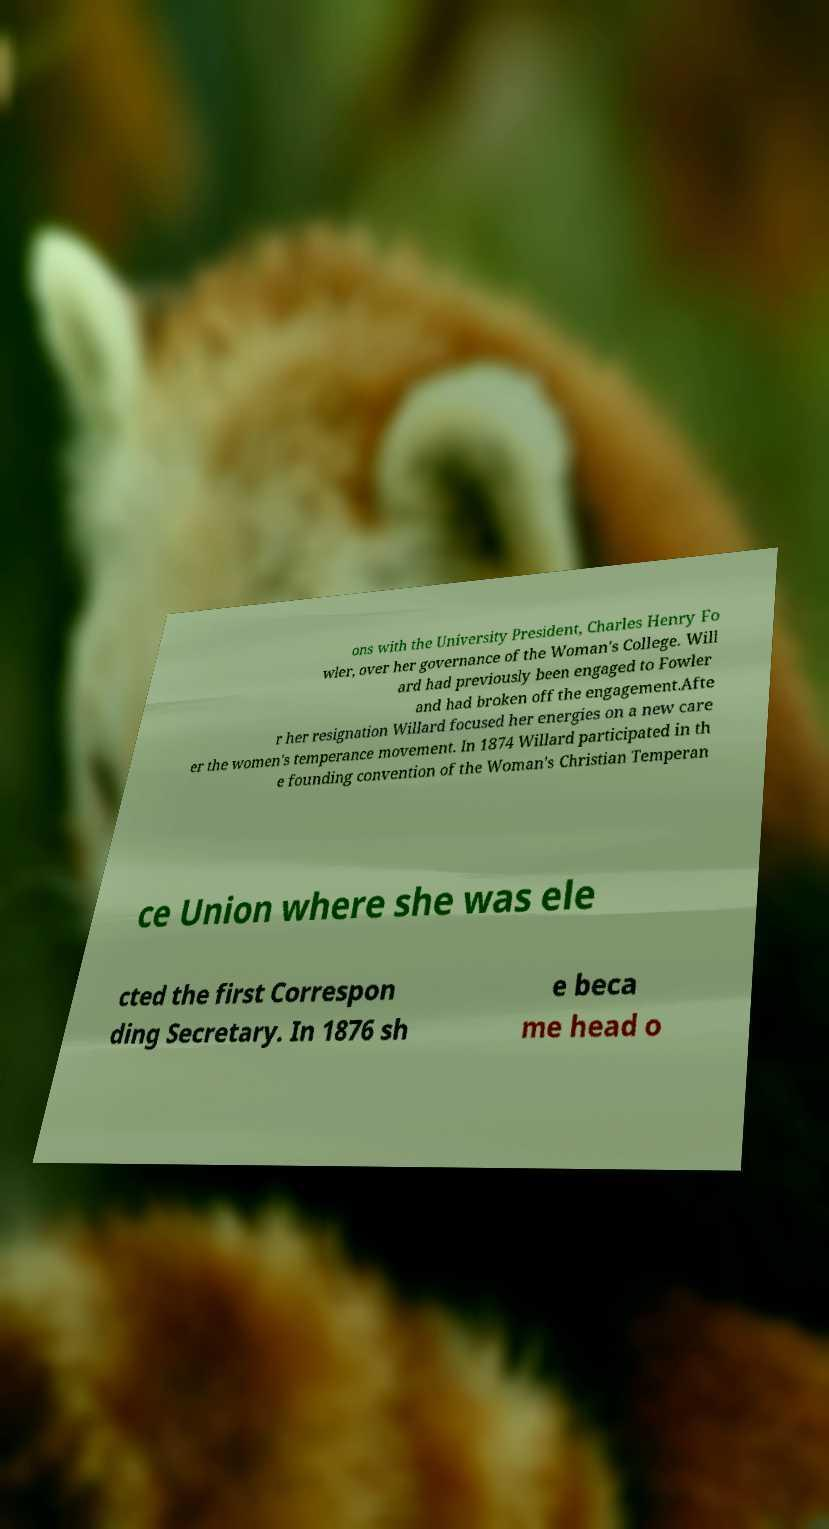There's text embedded in this image that I need extracted. Can you transcribe it verbatim? ons with the University President, Charles Henry Fo wler, over her governance of the Woman's College. Will ard had previously been engaged to Fowler and had broken off the engagement.Afte r her resignation Willard focused her energies on a new care er the women's temperance movement. In 1874 Willard participated in th e founding convention of the Woman's Christian Temperan ce Union where she was ele cted the first Correspon ding Secretary. In 1876 sh e beca me head o 